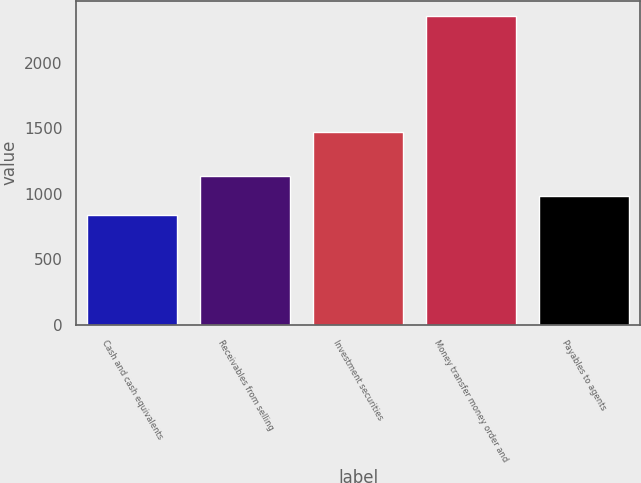Convert chart to OTSL. <chart><loc_0><loc_0><loc_500><loc_500><bar_chart><fcel>Cash and cash equivalents<fcel>Receivables from selling<fcel>Investment securities<fcel>Money transfer money order and<fcel>Payables to agents<nl><fcel>834.3<fcel>1138.78<fcel>1472.5<fcel>2356.7<fcel>986.54<nl></chart> 